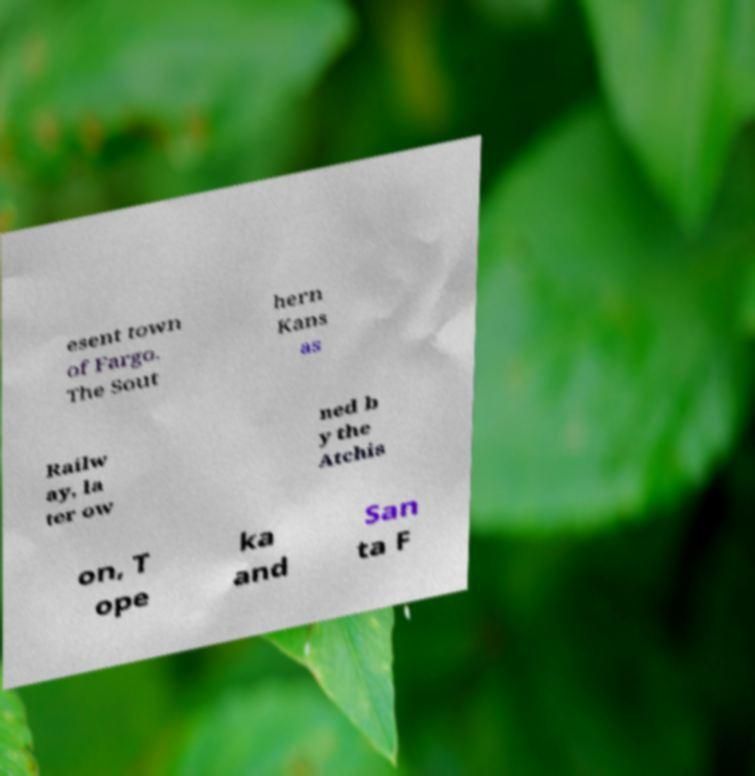For documentation purposes, I need the text within this image transcribed. Could you provide that? esent town of Fargo. The Sout hern Kans as Railw ay, la ter ow ned b y the Atchis on, T ope ka and San ta F 